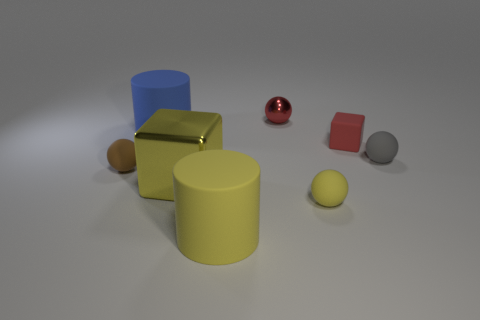There is a object that is on the left side of the big blue cylinder; is it the same shape as the small gray rubber thing?
Offer a terse response. Yes. Is the shape of the red thing on the left side of the tiny yellow matte ball the same as the small thing that is to the left of the blue cylinder?
Your response must be concise. Yes. What color is the other metallic thing that is the same shape as the brown thing?
Offer a very short reply. Red. What size is the red object that is the same shape as the tiny yellow object?
Provide a short and direct response. Small. What is the shape of the red object on the left side of the tiny red thing in front of the metallic sphere?
Offer a terse response. Sphere. What is the color of the small metallic ball?
Your answer should be compact. Red. What number of other objects are there of the same size as the blue matte thing?
Provide a succinct answer. 2. The small thing that is both in front of the gray matte ball and to the right of the small brown rubber object is made of what material?
Provide a succinct answer. Rubber. There is a matte cylinder behind the gray sphere; is its size the same as the small brown thing?
Provide a short and direct response. No. Do the tiny rubber block and the small metallic sphere have the same color?
Offer a terse response. Yes. 